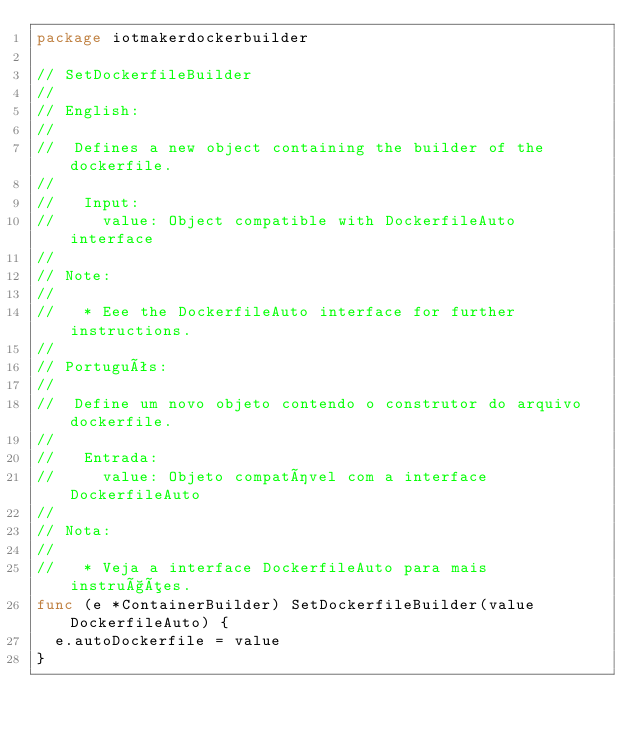<code> <loc_0><loc_0><loc_500><loc_500><_Go_>package iotmakerdockerbuilder

// SetDockerfileBuilder
//
// English:
//
//  Defines a new object containing the builder of the dockerfile.
//
//   Input:
//     value: Object compatible with DockerfileAuto interface
//
// Note:
//
//   * Eee the DockerfileAuto interface for further instructions.
//
// Português:
//
//  Define um novo objeto contendo o construtor do arquivo dockerfile.
//
//   Entrada:
//     value: Objeto compatível com a interface DockerfileAuto
//
// Nota:
//
//   * Veja a interface DockerfileAuto para mais instruções.
func (e *ContainerBuilder) SetDockerfileBuilder(value DockerfileAuto) {
	e.autoDockerfile = value
}
</code> 